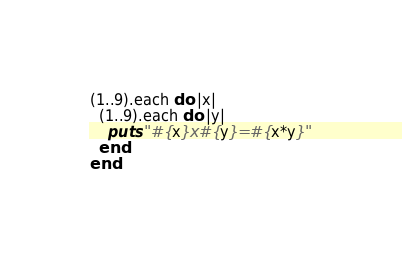Convert code to text. <code><loc_0><loc_0><loc_500><loc_500><_Ruby_>(1..9).each do |x|
  (1..9).each do |y|
    puts "#{x}x#{y}=#{x*y}"
  end
end

</code> 